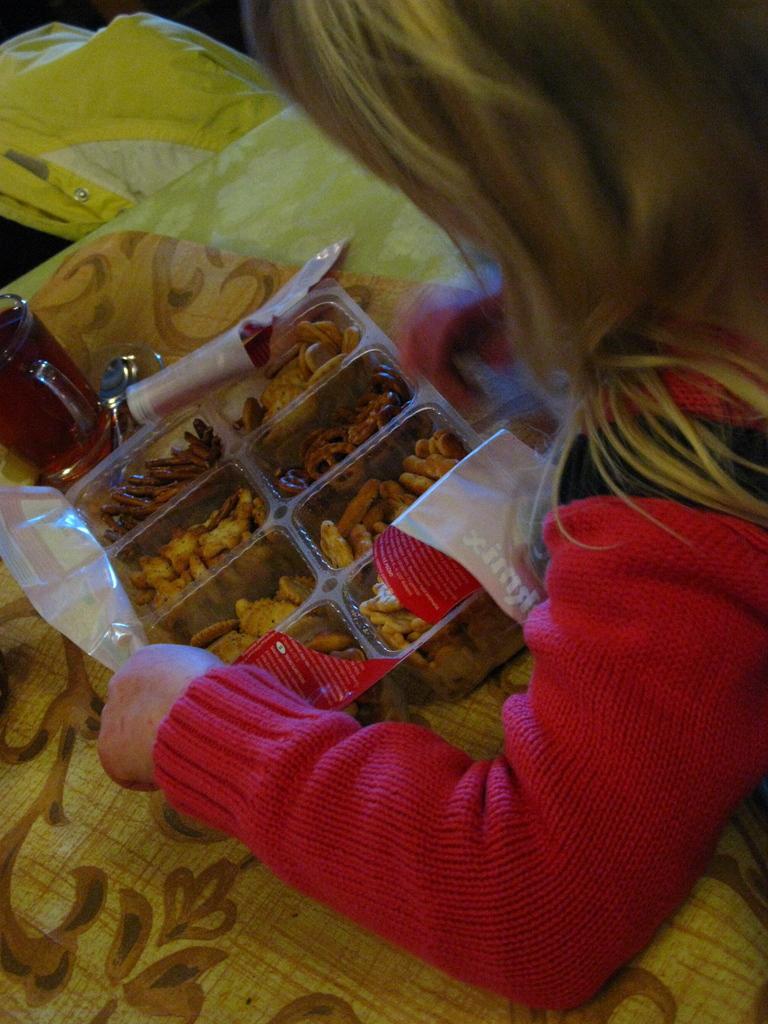How would you summarize this image in a sentence or two? This is a zoomed in picture. On the right there is a person seems to be on the ground. On the left there is a table on the top of which a cup and a box of snacks is placed. In the background we can see some other objects. 